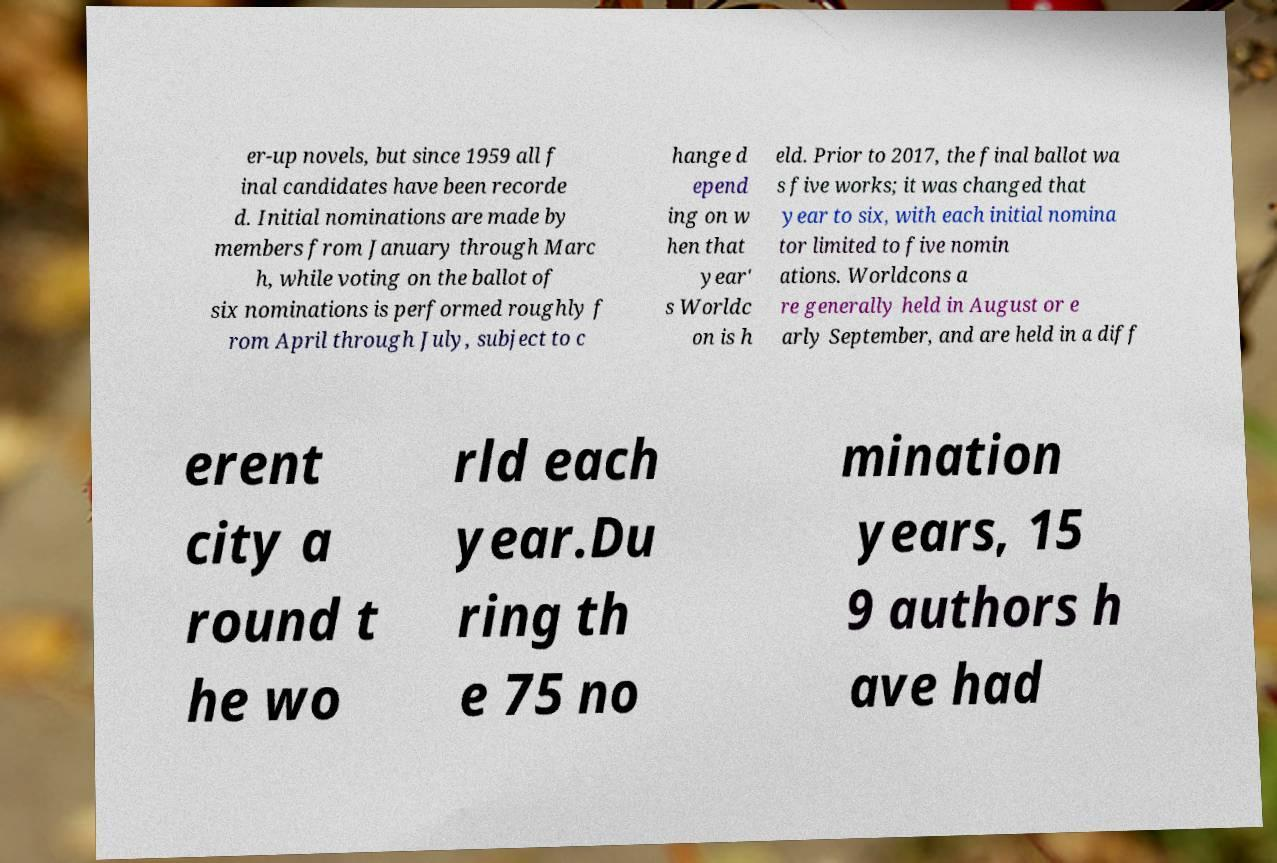Could you extract and type out the text from this image? er-up novels, but since 1959 all f inal candidates have been recorde d. Initial nominations are made by members from January through Marc h, while voting on the ballot of six nominations is performed roughly f rom April through July, subject to c hange d epend ing on w hen that year' s Worldc on is h eld. Prior to 2017, the final ballot wa s five works; it was changed that year to six, with each initial nomina tor limited to five nomin ations. Worldcons a re generally held in August or e arly September, and are held in a diff erent city a round t he wo rld each year.Du ring th e 75 no mination years, 15 9 authors h ave had 